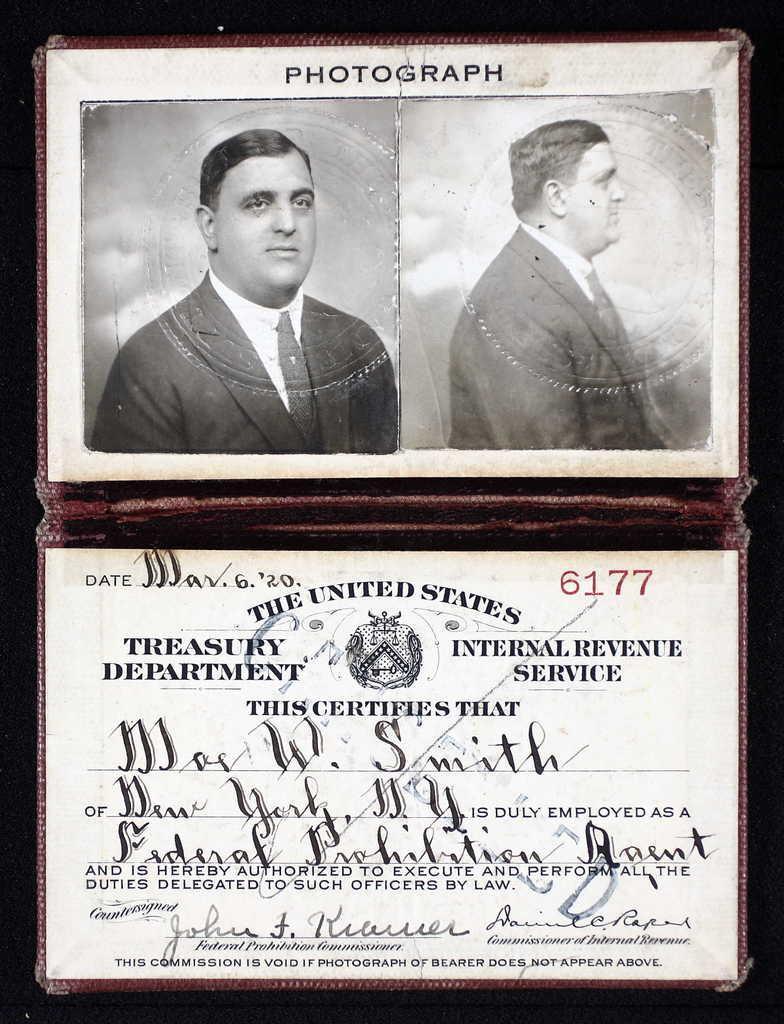Please provide a concise description of this image. In the picture I can see the photographs of a person at the top of the image and a card on which some text is printed at the bottom of the image and they are kept in the wallet. 